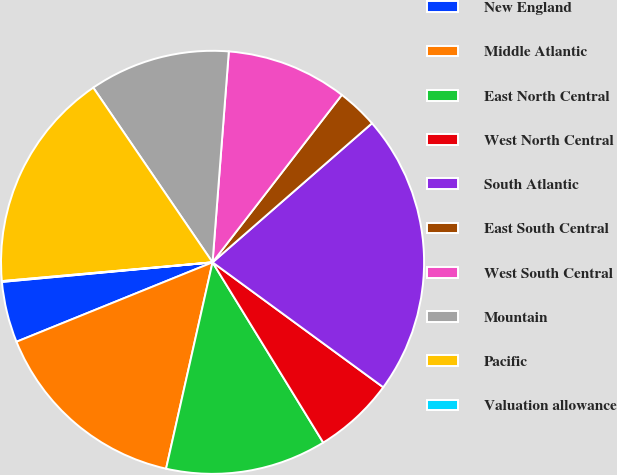<chart> <loc_0><loc_0><loc_500><loc_500><pie_chart><fcel>New England<fcel>Middle Atlantic<fcel>East North Central<fcel>West North Central<fcel>South Atlantic<fcel>East South Central<fcel>West South Central<fcel>Mountain<fcel>Pacific<fcel>Valuation allowance<nl><fcel>4.65%<fcel>15.35%<fcel>12.29%<fcel>6.18%<fcel>21.47%<fcel>3.12%<fcel>9.24%<fcel>10.76%<fcel>16.88%<fcel>0.06%<nl></chart> 